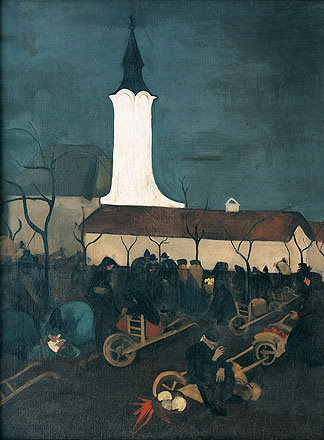What's happening in the scene? The image is an evocative oil painting showcasing a church scene, characterized by a towering white steeple that stands out against a somber, overcast sky. Surrounding the church, a congregation of people engaged in routine village life can be seen. Some figures are carrying tools like wheelbarrows and ladders, perhaps preparing for an event or maintaining the grounds. The attire of dark clothing merges with the evening hues, hinting at a collective somber mood or a seasonal gathering. This painting exemplifies post-impressionist influences with its stark color contrasts and abstract forms, inviting the viewer to ponder the harmonious existence between the spiritual stature of the church and daily village life. 